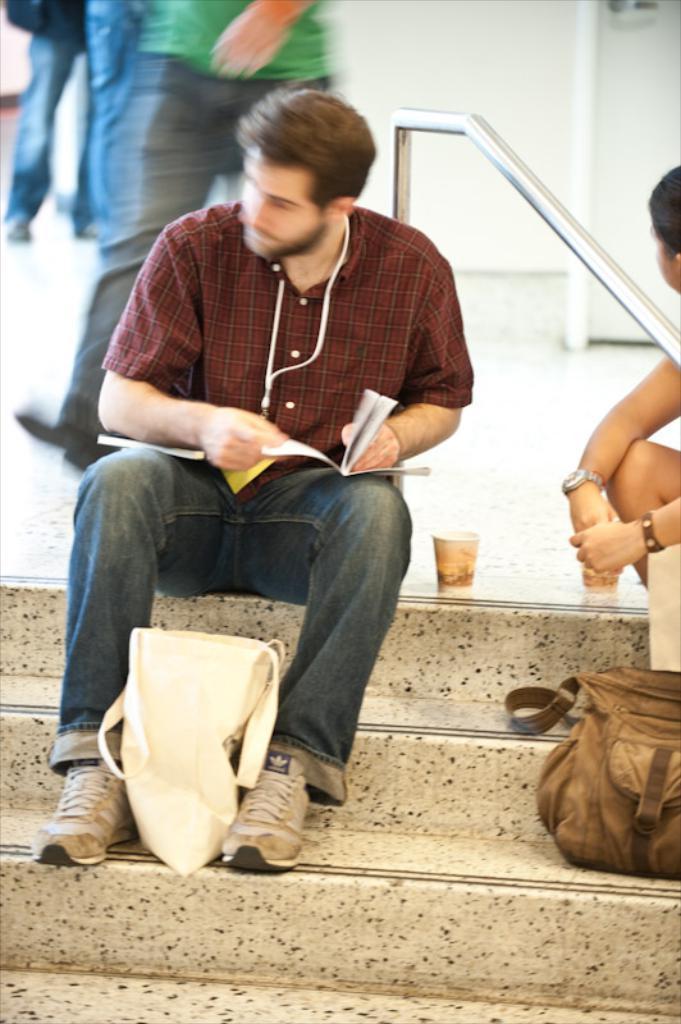How would you summarize this image in a sentence or two? In this picture I can see bags, cup, there are two persons sitting on the stairs, and in the background there are legs of persons. 